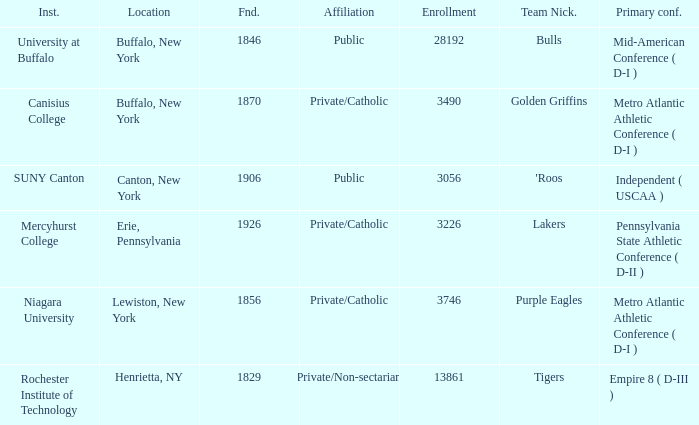Could you parse the entire table? {'header': ['Inst.', 'Location', 'Fnd.', 'Affiliation', 'Enrollment', 'Team Nick.', 'Primary conf.'], 'rows': [['University at Buffalo', 'Buffalo, New York', '1846', 'Public', '28192', 'Bulls', 'Mid-American Conference ( D-I )'], ['Canisius College', 'Buffalo, New York', '1870', 'Private/Catholic', '3490', 'Golden Griffins', 'Metro Atlantic Athletic Conference ( D-I )'], ['SUNY Canton', 'Canton, New York', '1906', 'Public', '3056', "'Roos", 'Independent ( USCAA )'], ['Mercyhurst College', 'Erie, Pennsylvania', '1926', 'Private/Catholic', '3226', 'Lakers', 'Pennsylvania State Athletic Conference ( D-II )'], ['Niagara University', 'Lewiston, New York', '1856', 'Private/Catholic', '3746', 'Purple Eagles', 'Metro Atlantic Athletic Conference ( D-I )'], ['Rochester Institute of Technology', 'Henrietta, NY', '1829', 'Private/Non-sectarian', '13861', 'Tigers', 'Empire 8 ( D-III )']]} What was the enrollment of the school founded in 1846? 28192.0. 